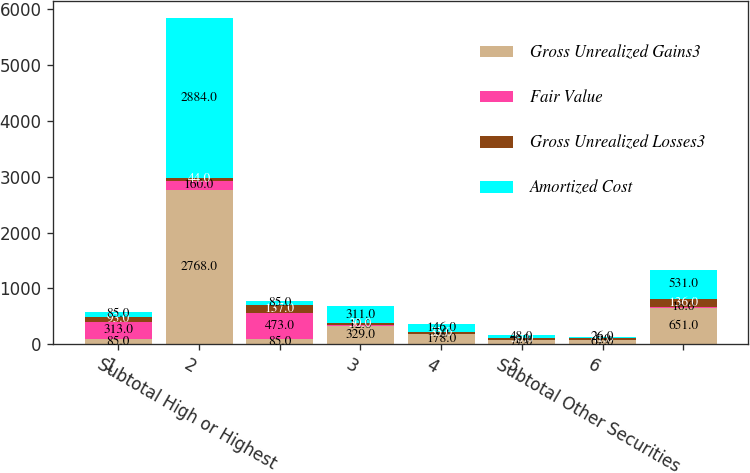Convert chart. <chart><loc_0><loc_0><loc_500><loc_500><stacked_bar_chart><ecel><fcel>1<fcel>2<fcel>Subtotal High or Highest<fcel>3<fcel>4<fcel>5<fcel>6<fcel>Subtotal Other Securities<nl><fcel>Gross Unrealized Gains3<fcel>85<fcel>2768<fcel>85<fcel>329<fcel>178<fcel>77<fcel>67<fcel>651<nl><fcel>Fair Value<fcel>313<fcel>160<fcel>473<fcel>12<fcel>3<fcel>1<fcel>0<fcel>16<nl><fcel>Gross Unrealized Losses3<fcel>93<fcel>44<fcel>137<fcel>30<fcel>35<fcel>30<fcel>41<fcel>136<nl><fcel>Amortized Cost<fcel>85<fcel>2884<fcel>85<fcel>311<fcel>146<fcel>48<fcel>26<fcel>531<nl></chart> 